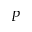<formula> <loc_0><loc_0><loc_500><loc_500>P</formula> 